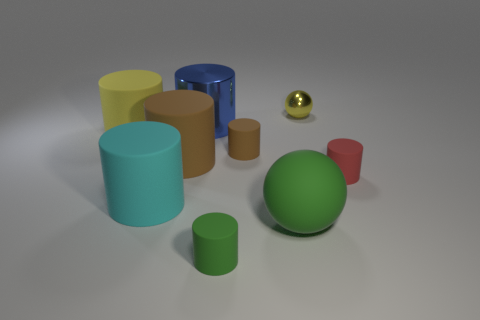How big is the ball that is right of the large rubber object that is to the right of the small green rubber cylinder?
Offer a terse response. Small. Is the number of small red matte objects that are right of the large blue object less than the number of small cyan rubber cylinders?
Your answer should be compact. No. Is the tiny metallic sphere the same color as the large metallic thing?
Give a very brief answer. No. What size is the red cylinder?
Give a very brief answer. Small. How many matte cylinders have the same color as the small metallic sphere?
Offer a terse response. 1. There is a large rubber thing on the right side of the big blue metallic thing that is to the left of the small green cylinder; are there any blue cylinders that are on the right side of it?
Ensure brevity in your answer.  No. There is a red matte object that is the same size as the green cylinder; what shape is it?
Your response must be concise. Cylinder. How many small things are either green objects or balls?
Your answer should be compact. 2. What color is the large ball that is the same material as the big yellow cylinder?
Your answer should be compact. Green. There is a yellow object to the right of the large cyan matte thing; does it have the same shape as the large matte object that is on the right side of the blue thing?
Offer a very short reply. Yes. 